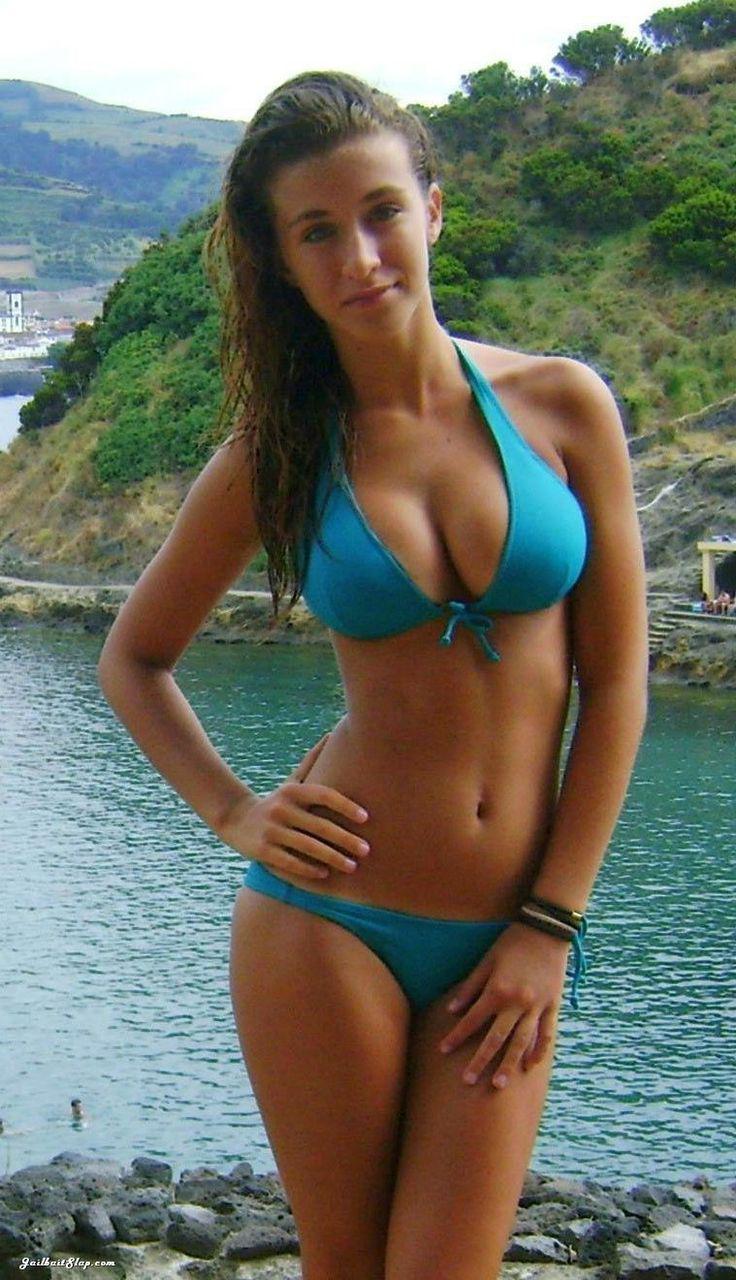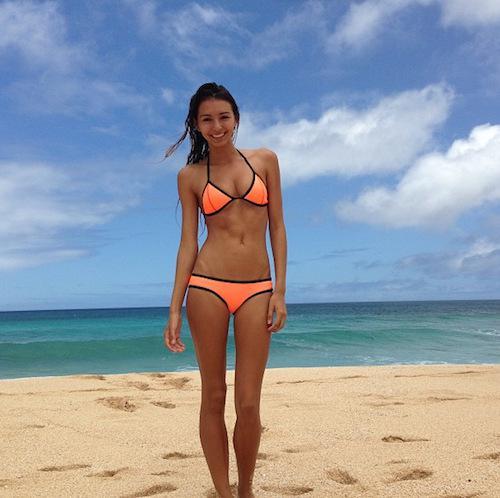The first image is the image on the left, the second image is the image on the right. Analyze the images presented: Is the assertion "All of the models are shown from the front, and are wearing tops that can be seen to loop around the neck." valid? Answer yes or no. Yes. The first image is the image on the left, the second image is the image on the right. Analyze the images presented: Is the assertion "The woman on the left has on a light blue bikini." valid? Answer yes or no. Yes. 